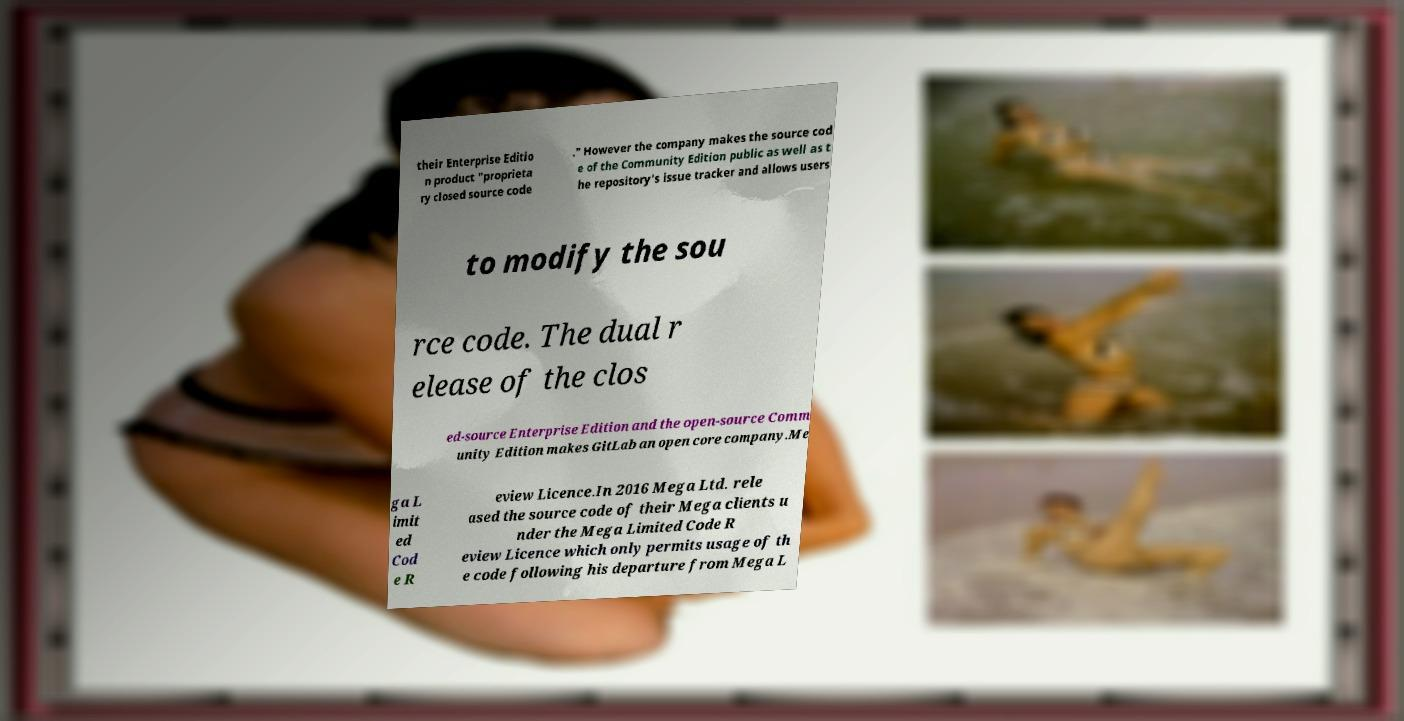Can you accurately transcribe the text from the provided image for me? their Enterprise Editio n product "proprieta ry closed source code ." However the company makes the source cod e of the Community Edition public as well as t he repository's issue tracker and allows users to modify the sou rce code. The dual r elease of the clos ed-source Enterprise Edition and the open-source Comm unity Edition makes GitLab an open core company.Me ga L imit ed Cod e R eview Licence.In 2016 Mega Ltd. rele ased the source code of their Mega clients u nder the Mega Limited Code R eview Licence which only permits usage of th e code following his departure from Mega L 